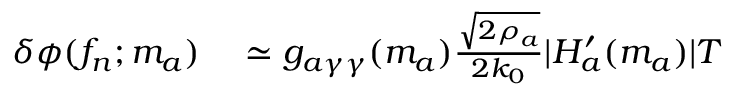Convert formula to latex. <formula><loc_0><loc_0><loc_500><loc_500>\begin{array} { r l } { \delta \phi ( f _ { n } ; m _ { a } ) } & \simeq g _ { a \gamma \gamma } ( m _ { a } ) \frac { \sqrt { 2 \rho _ { a } } } { 2 k _ { 0 } } | H _ { a } ^ { \prime } ( m _ { a } ) | T } \end{array}</formula> 